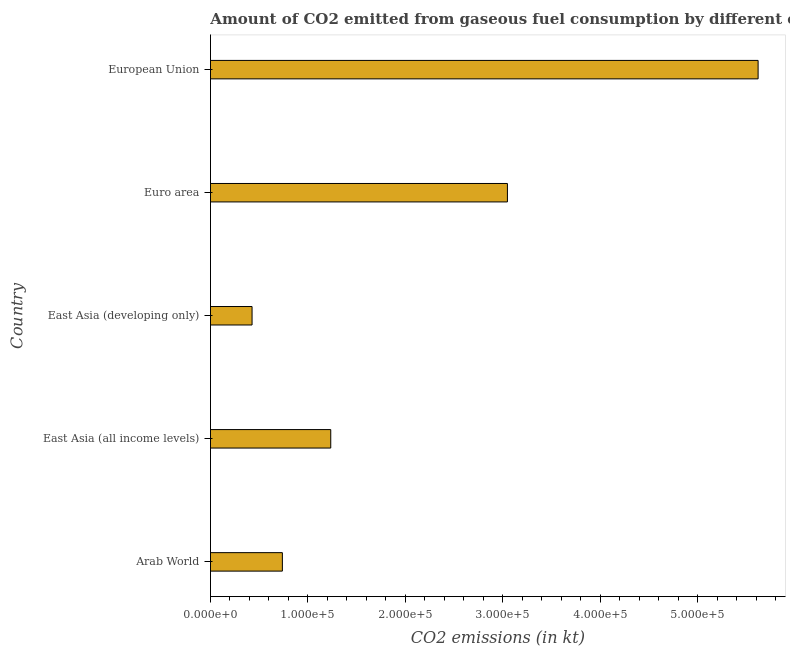Does the graph contain any zero values?
Your response must be concise. No. Does the graph contain grids?
Your answer should be very brief. No. What is the title of the graph?
Provide a succinct answer. Amount of CO2 emitted from gaseous fuel consumption by different countries in 1982. What is the label or title of the X-axis?
Provide a succinct answer. CO2 emissions (in kt). What is the co2 emissions from gaseous fuel consumption in European Union?
Your answer should be very brief. 5.62e+05. Across all countries, what is the maximum co2 emissions from gaseous fuel consumption?
Give a very brief answer. 5.62e+05. Across all countries, what is the minimum co2 emissions from gaseous fuel consumption?
Give a very brief answer. 4.27e+04. In which country was the co2 emissions from gaseous fuel consumption minimum?
Offer a very short reply. East Asia (developing only). What is the sum of the co2 emissions from gaseous fuel consumption?
Keep it short and to the point. 1.11e+06. What is the difference between the co2 emissions from gaseous fuel consumption in East Asia (all income levels) and East Asia (developing only)?
Your answer should be very brief. 8.07e+04. What is the average co2 emissions from gaseous fuel consumption per country?
Provide a succinct answer. 2.21e+05. What is the median co2 emissions from gaseous fuel consumption?
Offer a very short reply. 1.23e+05. In how many countries, is the co2 emissions from gaseous fuel consumption greater than 180000 kt?
Make the answer very short. 2. What is the ratio of the co2 emissions from gaseous fuel consumption in Arab World to that in East Asia (all income levels)?
Make the answer very short. 0.6. Is the co2 emissions from gaseous fuel consumption in East Asia (developing only) less than that in European Union?
Make the answer very short. Yes. Is the difference between the co2 emissions from gaseous fuel consumption in Arab World and East Asia (all income levels) greater than the difference between any two countries?
Offer a very short reply. No. What is the difference between the highest and the second highest co2 emissions from gaseous fuel consumption?
Your response must be concise. 2.57e+05. What is the difference between the highest and the lowest co2 emissions from gaseous fuel consumption?
Your answer should be very brief. 5.19e+05. Are the values on the major ticks of X-axis written in scientific E-notation?
Offer a terse response. Yes. What is the CO2 emissions (in kt) of Arab World?
Provide a succinct answer. 7.38e+04. What is the CO2 emissions (in kt) of East Asia (all income levels)?
Keep it short and to the point. 1.23e+05. What is the CO2 emissions (in kt) in East Asia (developing only)?
Provide a succinct answer. 4.27e+04. What is the CO2 emissions (in kt) of Euro area?
Provide a succinct answer. 3.05e+05. What is the CO2 emissions (in kt) in European Union?
Provide a succinct answer. 5.62e+05. What is the difference between the CO2 emissions (in kt) in Arab World and East Asia (all income levels)?
Ensure brevity in your answer.  -4.96e+04. What is the difference between the CO2 emissions (in kt) in Arab World and East Asia (developing only)?
Your response must be concise. 3.11e+04. What is the difference between the CO2 emissions (in kt) in Arab World and Euro area?
Offer a very short reply. -2.31e+05. What is the difference between the CO2 emissions (in kt) in Arab World and European Union?
Your answer should be very brief. -4.88e+05. What is the difference between the CO2 emissions (in kt) in East Asia (all income levels) and East Asia (developing only)?
Your response must be concise. 8.07e+04. What is the difference between the CO2 emissions (in kt) in East Asia (all income levels) and Euro area?
Ensure brevity in your answer.  -1.81e+05. What is the difference between the CO2 emissions (in kt) in East Asia (all income levels) and European Union?
Your response must be concise. -4.38e+05. What is the difference between the CO2 emissions (in kt) in East Asia (developing only) and Euro area?
Offer a very short reply. -2.62e+05. What is the difference between the CO2 emissions (in kt) in East Asia (developing only) and European Union?
Your answer should be very brief. -5.19e+05. What is the difference between the CO2 emissions (in kt) in Euro area and European Union?
Ensure brevity in your answer.  -2.57e+05. What is the ratio of the CO2 emissions (in kt) in Arab World to that in East Asia (all income levels)?
Make the answer very short. 0.6. What is the ratio of the CO2 emissions (in kt) in Arab World to that in East Asia (developing only)?
Offer a very short reply. 1.73. What is the ratio of the CO2 emissions (in kt) in Arab World to that in Euro area?
Your answer should be compact. 0.24. What is the ratio of the CO2 emissions (in kt) in Arab World to that in European Union?
Provide a succinct answer. 0.13. What is the ratio of the CO2 emissions (in kt) in East Asia (all income levels) to that in East Asia (developing only)?
Your response must be concise. 2.89. What is the ratio of the CO2 emissions (in kt) in East Asia (all income levels) to that in Euro area?
Give a very brief answer. 0.41. What is the ratio of the CO2 emissions (in kt) in East Asia (all income levels) to that in European Union?
Offer a very short reply. 0.22. What is the ratio of the CO2 emissions (in kt) in East Asia (developing only) to that in Euro area?
Keep it short and to the point. 0.14. What is the ratio of the CO2 emissions (in kt) in East Asia (developing only) to that in European Union?
Your answer should be compact. 0.08. What is the ratio of the CO2 emissions (in kt) in Euro area to that in European Union?
Offer a very short reply. 0.54. 